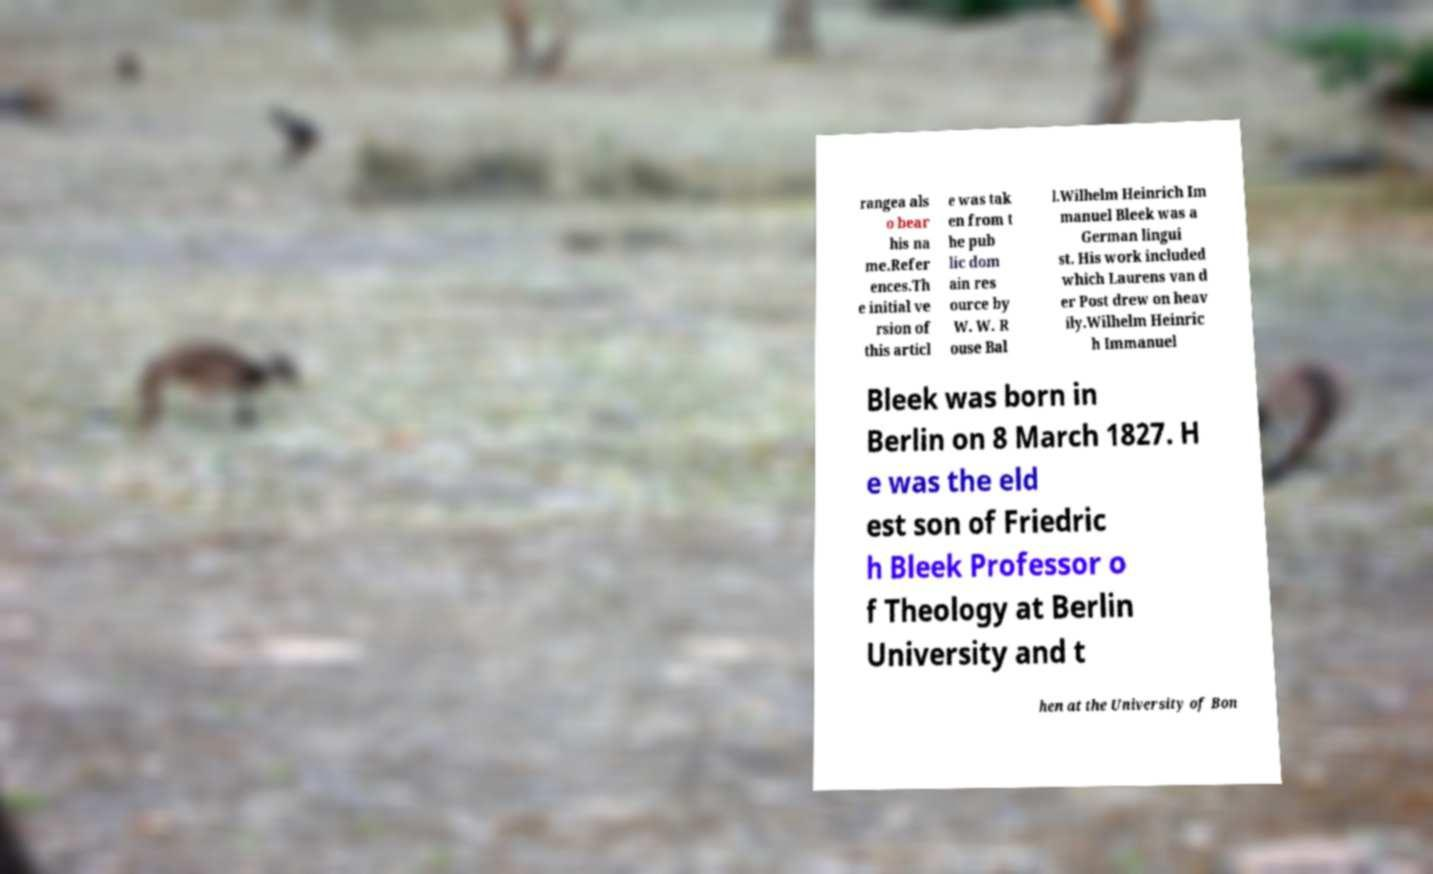Can you read and provide the text displayed in the image?This photo seems to have some interesting text. Can you extract and type it out for me? rangea als o bear his na me.Refer ences.Th e initial ve rsion of this articl e was tak en from t he pub lic dom ain res ource by W. W. R ouse Bal l.Wilhelm Heinrich Im manuel Bleek was a German lingui st. His work included which Laurens van d er Post drew on heav ily.Wilhelm Heinric h Immanuel Bleek was born in Berlin on 8 March 1827. H e was the eld est son of Friedric h Bleek Professor o f Theology at Berlin University and t hen at the University of Bon 